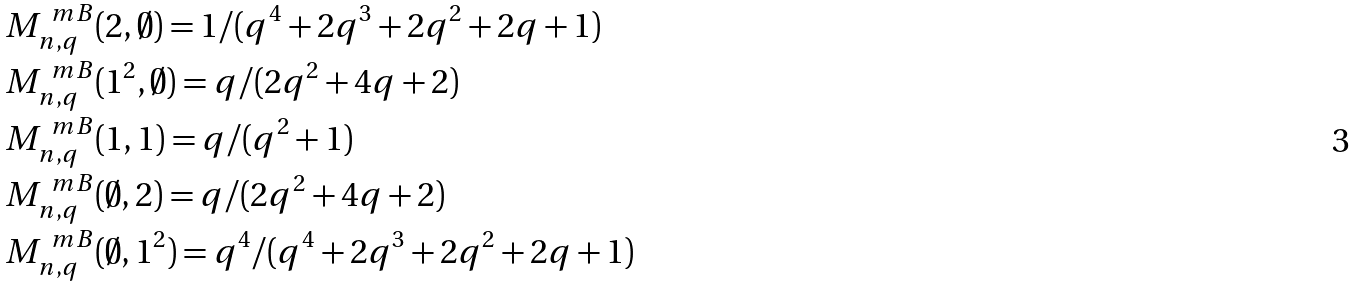Convert formula to latex. <formula><loc_0><loc_0><loc_500><loc_500>& M ^ { \ m B } _ { n , q } ( 2 , \emptyset ) = 1 / ( q ^ { 4 } + 2 q ^ { 3 } + 2 q ^ { 2 } + 2 q + 1 ) \\ & M ^ { \ m B } _ { n , q } ( 1 ^ { 2 } , \emptyset ) = q / ( 2 q ^ { 2 } + 4 q + 2 ) \\ & M ^ { \ m B } _ { n , q } ( 1 , 1 ) = q / ( q ^ { 2 } + 1 ) \\ & M ^ { \ m B } _ { n , q } ( \emptyset , 2 ) = q / ( 2 q ^ { 2 } + 4 q + 2 ) \\ & M ^ { \ m B } _ { n , q } ( \emptyset , 1 ^ { 2 } ) = q ^ { 4 } / ( q ^ { 4 } + 2 q ^ { 3 } + 2 q ^ { 2 } + 2 q + 1 )</formula> 